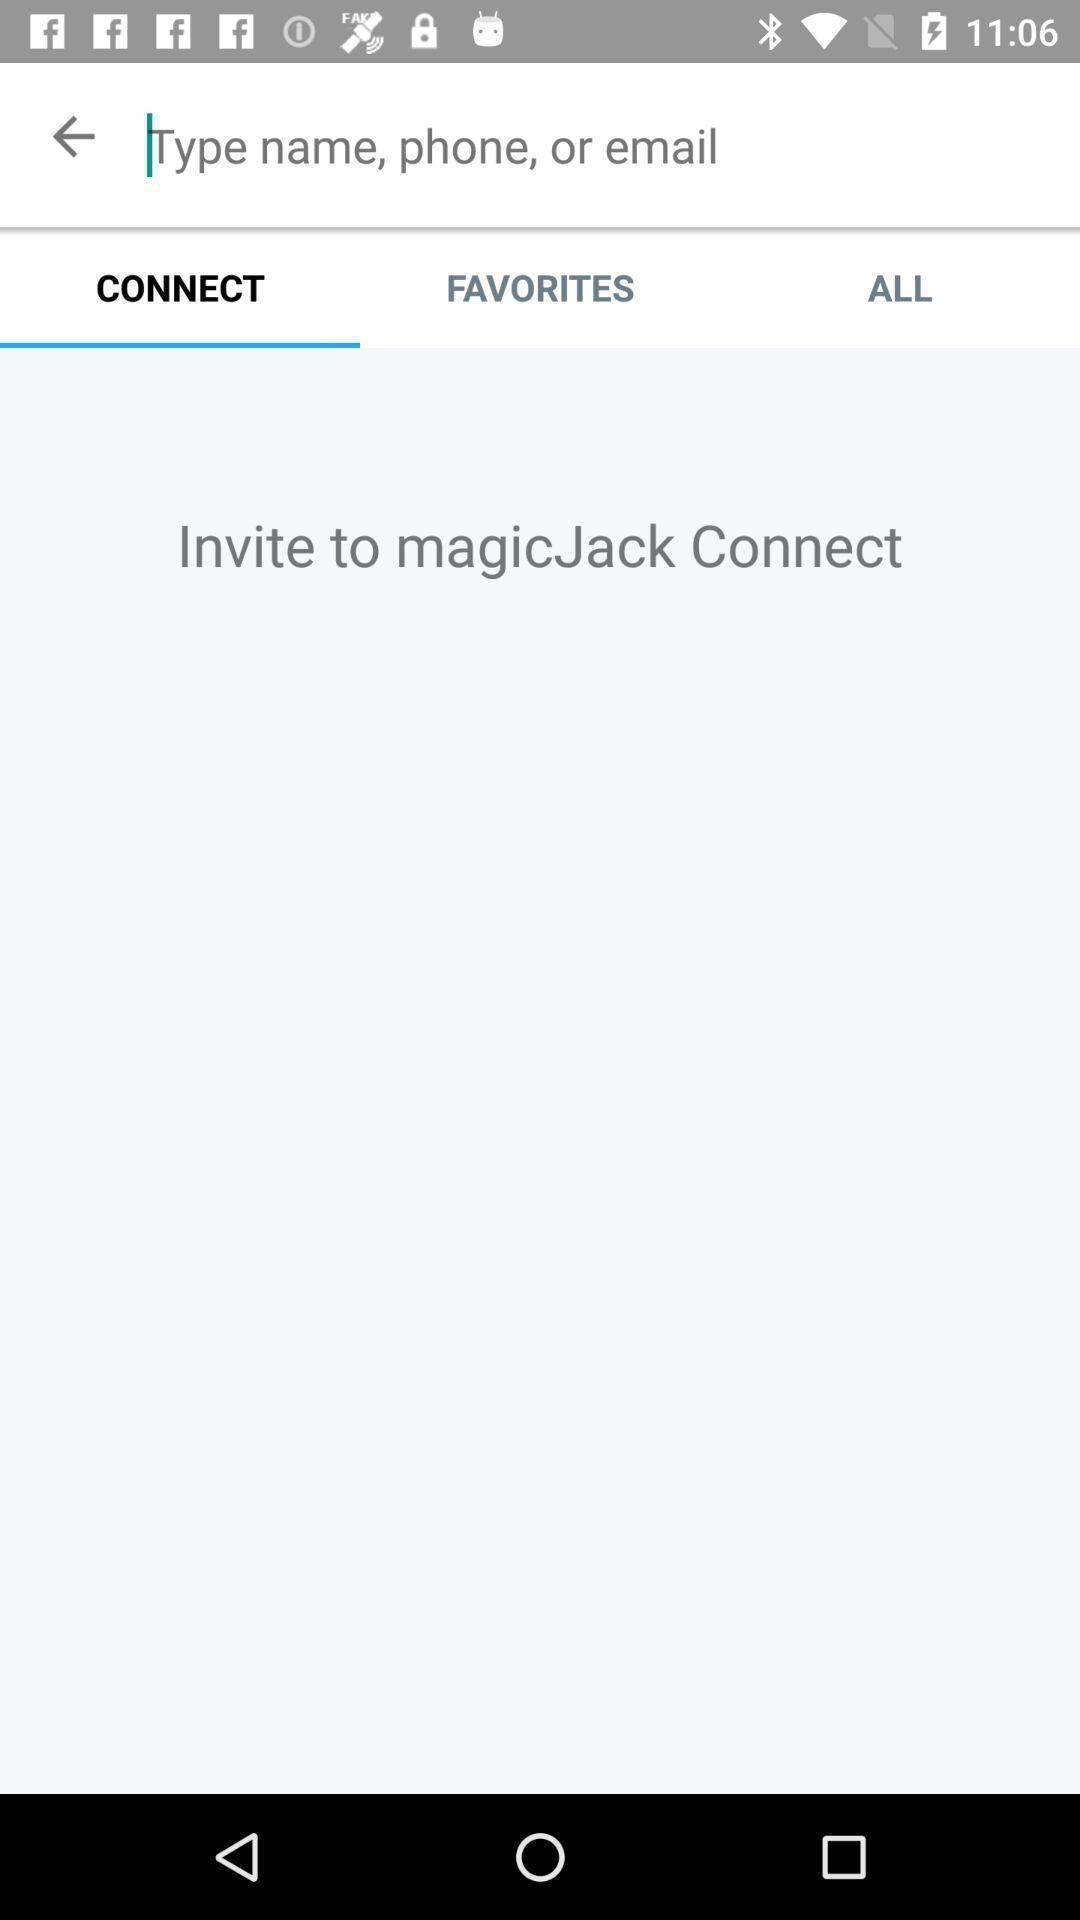Give me a summary of this screen capture. Search bar to search for the contacts. 